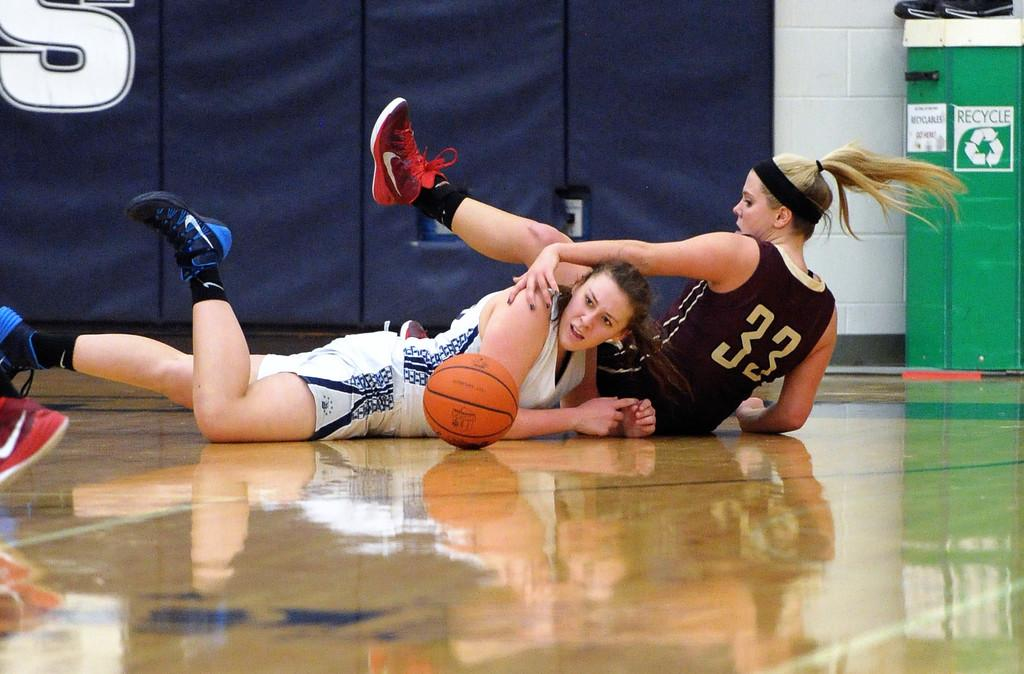<image>
Offer a succinct explanation of the picture presented. Number 33 is shown on the uniform of the girl fighting for the ball. 